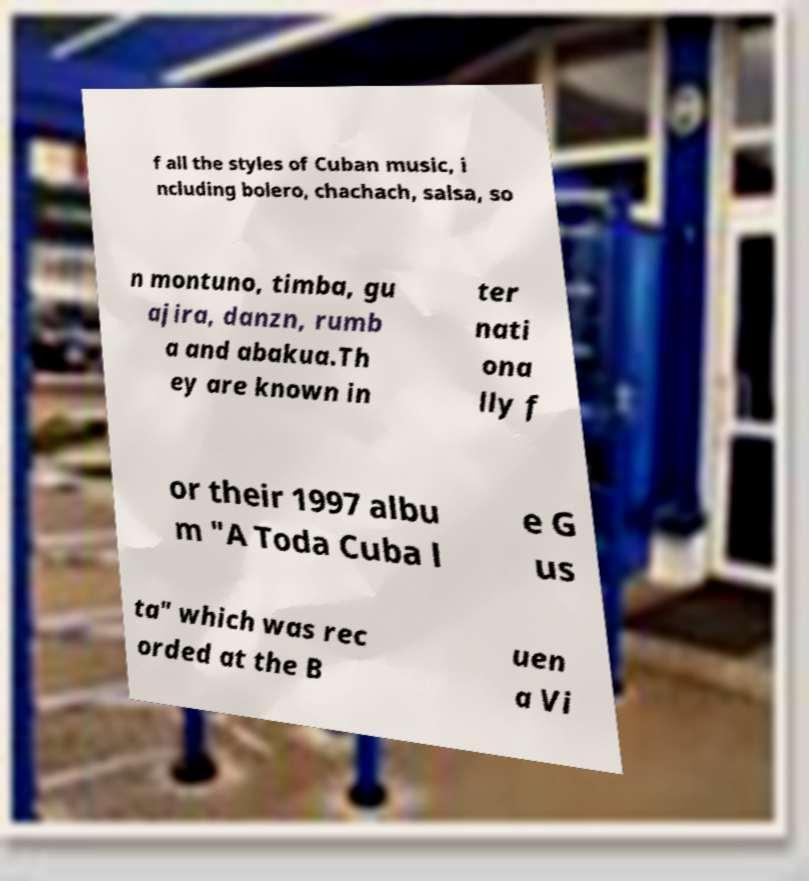Please read and relay the text visible in this image. What does it say? f all the styles of Cuban music, i ncluding bolero, chachach, salsa, so n montuno, timba, gu ajira, danzn, rumb a and abakua.Th ey are known in ter nati ona lly f or their 1997 albu m "A Toda Cuba l e G us ta" which was rec orded at the B uen a Vi 